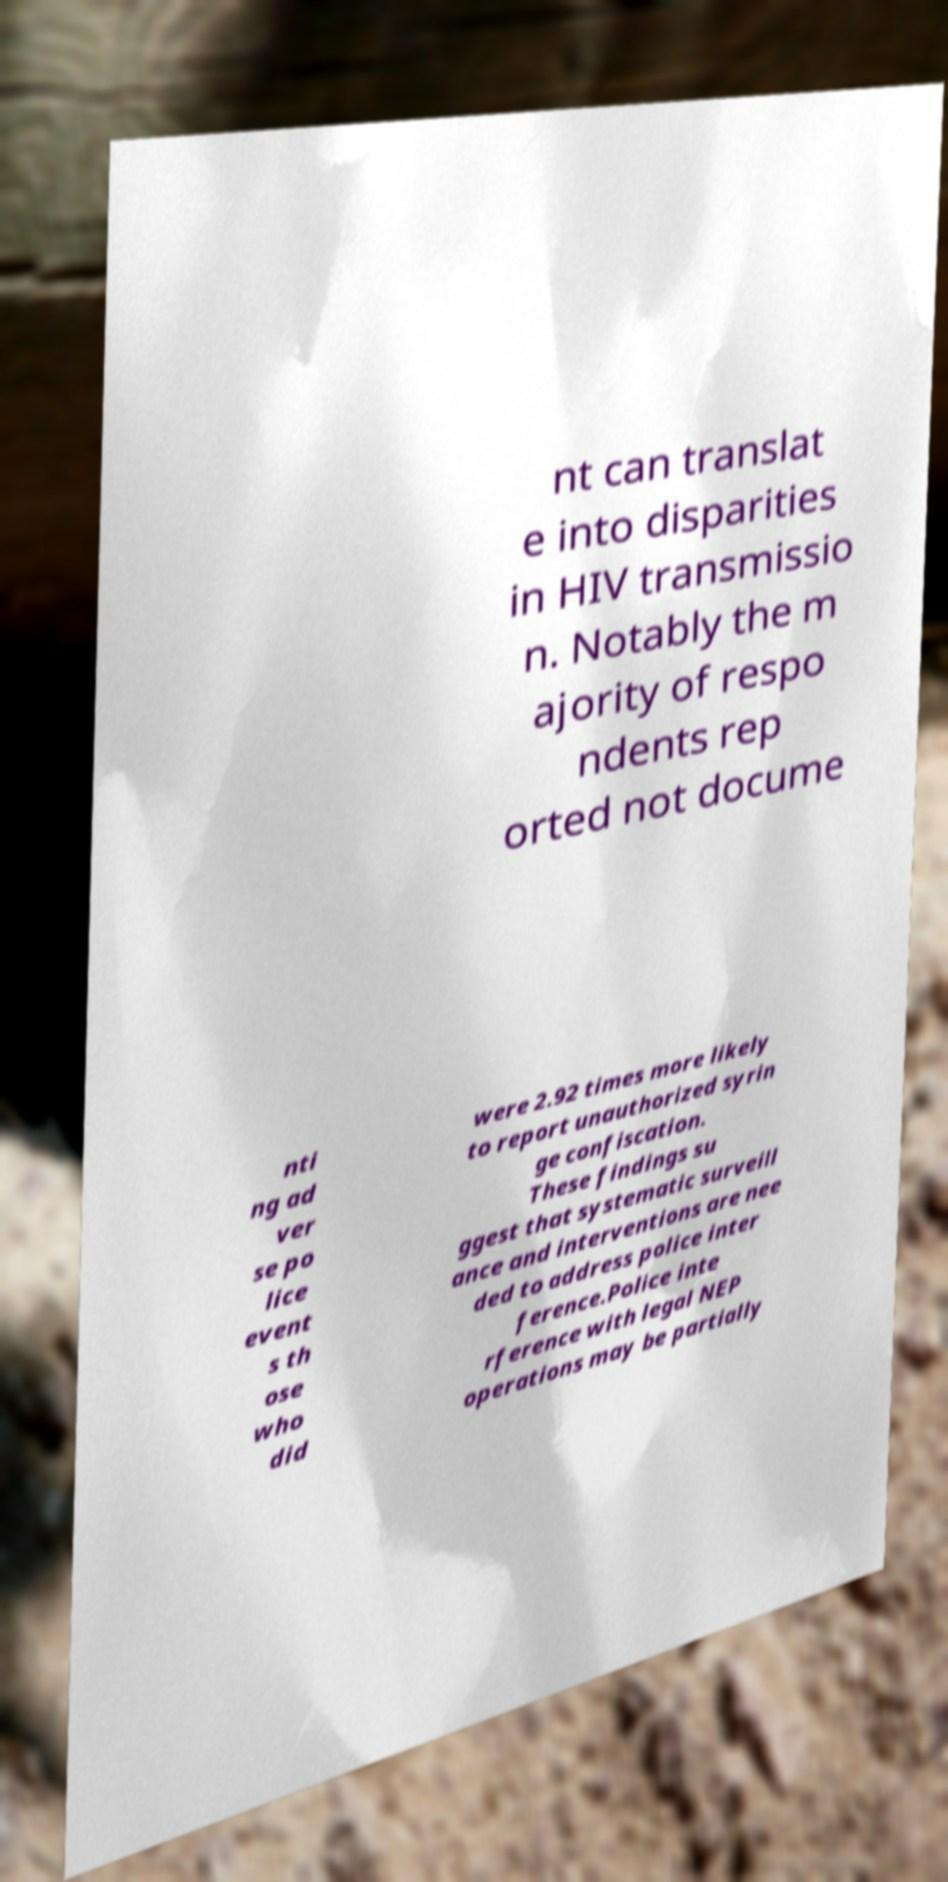Could you assist in decoding the text presented in this image and type it out clearly? nt can translat e into disparities in HIV transmissio n. Notably the m ajority of respo ndents rep orted not docume nti ng ad ver se po lice event s th ose who did were 2.92 times more likely to report unauthorized syrin ge confiscation. These findings su ggest that systematic surveill ance and interventions are nee ded to address police inter ference.Police inte rference with legal NEP operations may be partially 